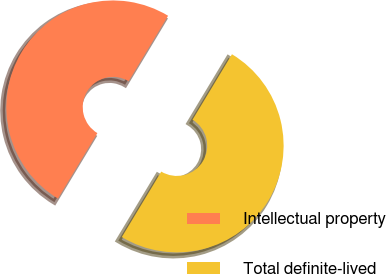Convert chart to OTSL. <chart><loc_0><loc_0><loc_500><loc_500><pie_chart><fcel>Intellectual property<fcel>Total definite-lived<nl><fcel>50.0%<fcel>50.0%<nl></chart> 